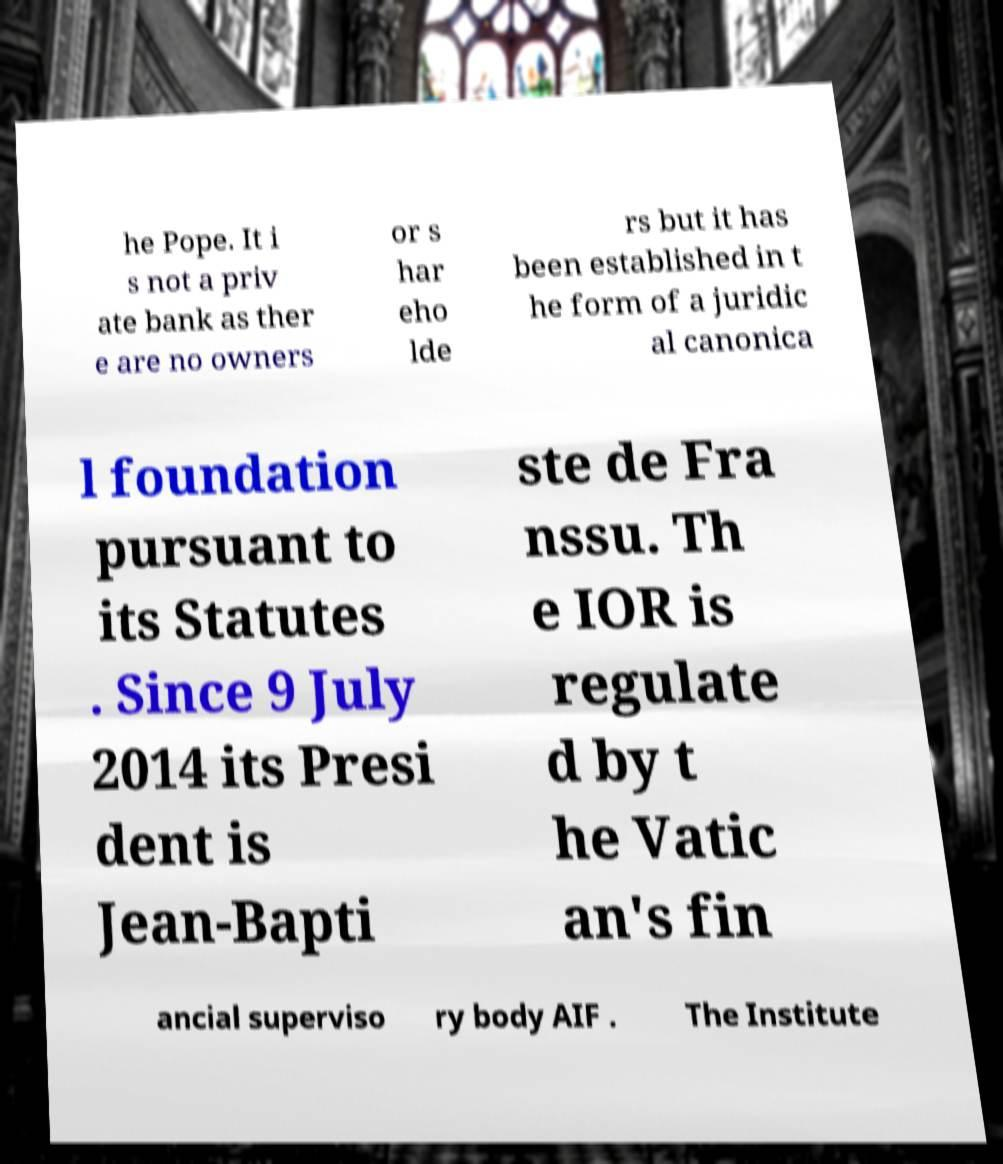There's text embedded in this image that I need extracted. Can you transcribe it verbatim? he Pope. It i s not a priv ate bank as ther e are no owners or s har eho lde rs but it has been established in t he form of a juridic al canonica l foundation pursuant to its Statutes . Since 9 July 2014 its Presi dent is Jean-Bapti ste de Fra nssu. Th e IOR is regulate d by t he Vatic an's fin ancial superviso ry body AIF . The Institute 